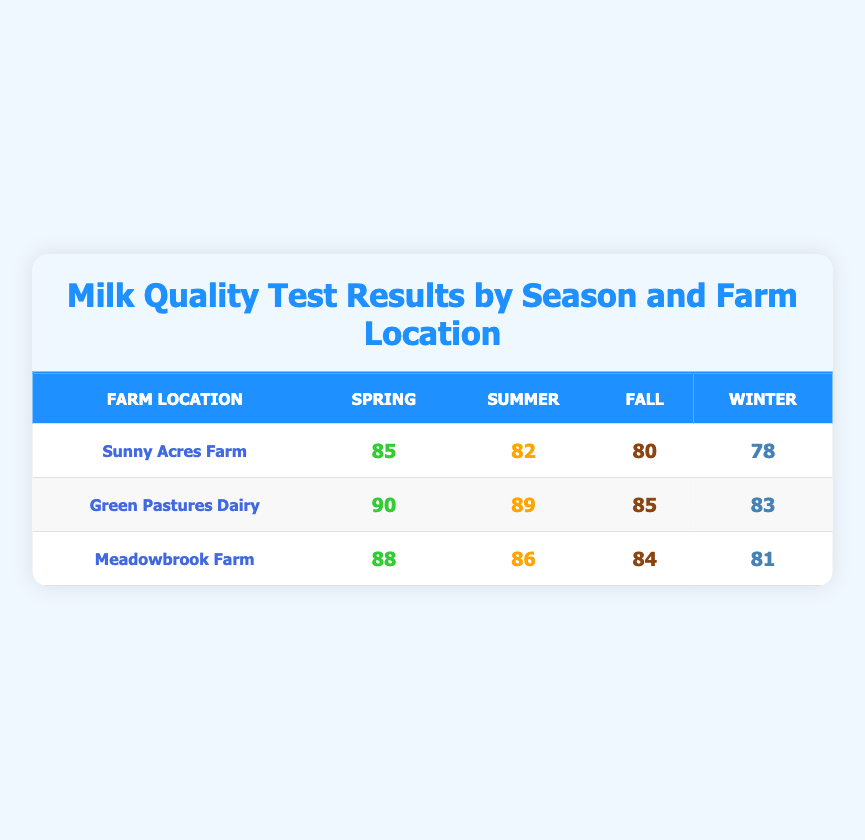What is the milk quality score for Sunny Acres Farm in Spring? Looking at the table, Sunny Acres Farm has a milk quality score of 85 listed under the Spring column.
Answer: 85 Which farm had the highest milk quality score in Summer? In the Summer column, Green Pastures Dairy has the highest score of 89 compared to Sunny Acres Farm (82) and Meadowbrook Farm (86).
Answer: Green Pastures Dairy What is the average milk quality score for Meadowbrook Farm across all seasons? First, we sum the scores for Meadowbrook Farm: 88 (Spring) + 86 (Summer) + 84 (Fall) + 81 (Winter) = 339. There are 4 seasons, so the average is 339 / 4 = 84.75.
Answer: 84.75 Did Green Pastures Dairy have a higher milk quality score in Fall compared to Winter? Looking at the scores, Green Pastures Dairy scored 85 in Fall and 83 in Winter. Since 85 is greater than 83, the statement is true.
Answer: Yes What is the difference in milk quality score between Sunny Acres Farm and Green Pastures Dairy in Winter? For Sunny Acres Farm in Winter, the score is 78, and for Green Pastures Dairy, it is 83. The difference is 83 - 78 = 5.
Answer: 5 Which season had the lowest average milk quality score across all farms? First, we find the average scores for each season: Spring (85 + 90 + 88) / 3 = 87.67, Summer (82 + 89 + 86) / 3 = 85.67, Fall (80 + 85 + 84) / 3 = 83, Winter (78 + 83 + 81) / 3 = 80.67. The lowest average is Winter at 80.67.
Answer: Winter Was the milk quality score for Sunny Acres Farm in Fall higher than the score for Meadowbrook Farm in Summer? Sunny Acres Farm scored 80 in Fall, while Meadowbrook Farm scored 86 in Summer. Since 80 is less than 86, the statement is false.
Answer: No What is the trend in milk quality scores for Sunny Acres Farm from Spring to Winter? The scores for Sunny Acres Farm are 85 (Spring), 82 (Summer), 80 (Fall), and 78 (Winter). The scores are decreasing with each season, indicating a downward trend.
Answer: Decreasing trend 